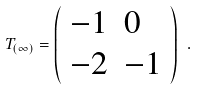Convert formula to latex. <formula><loc_0><loc_0><loc_500><loc_500>T _ { ( \infty ) } = \left ( \begin{array} { l l } { - 1 } & { 0 } \\ { - 2 } & { - 1 } \end{array} \right ) \ .</formula> 